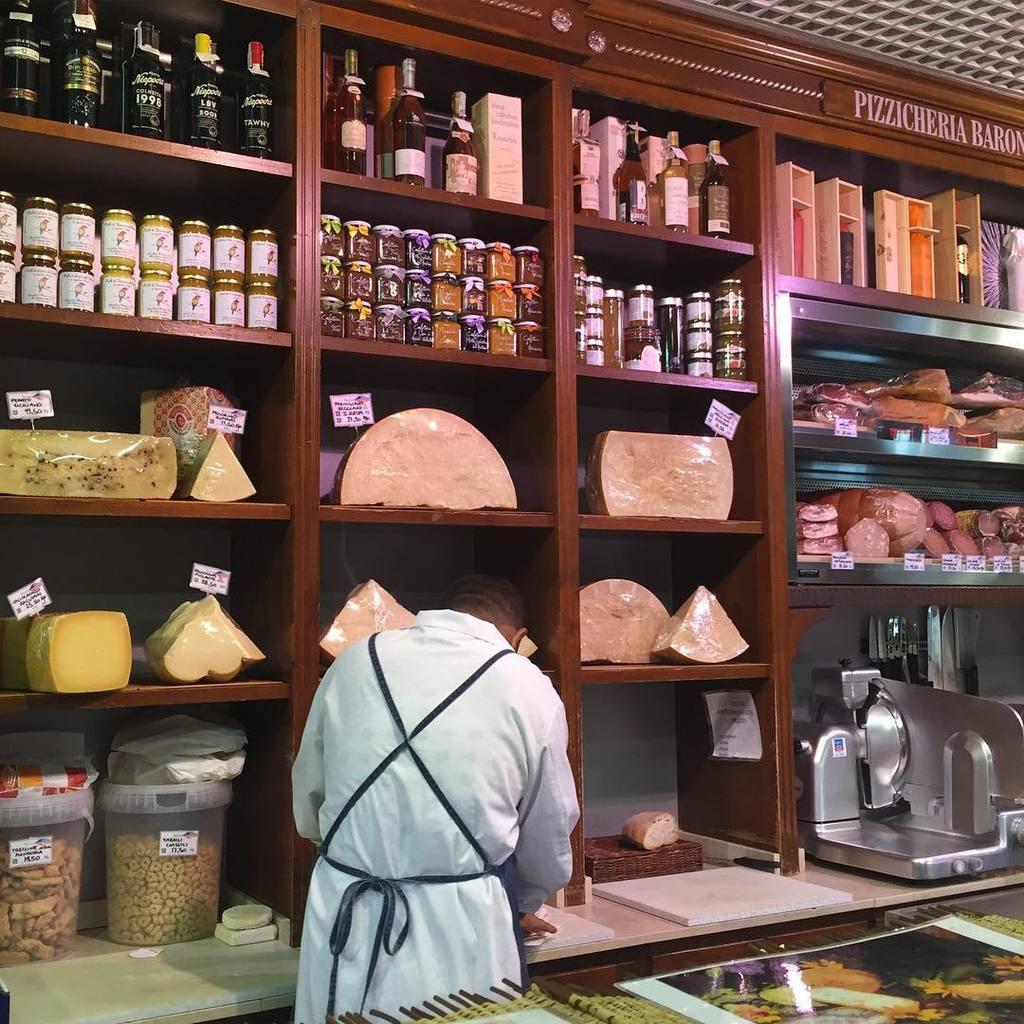Can you describe this image briefly? In this picture we can see a person standing and in front of him we can see bottles, jars and some objects with price tags in racks and at the back of him we can see posters and some objects. 